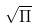<formula> <loc_0><loc_0><loc_500><loc_500>\sqrt { \Pi }</formula> 